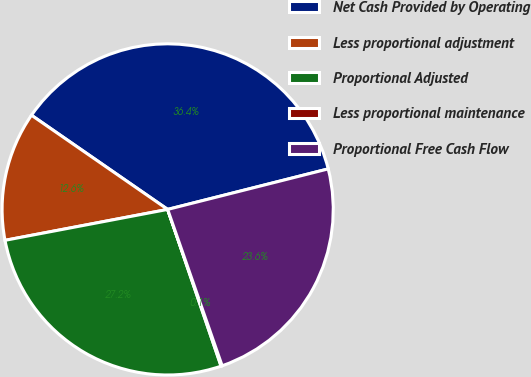<chart> <loc_0><loc_0><loc_500><loc_500><pie_chart><fcel>Net Cash Provided by Operating<fcel>Less proportional adjustment<fcel>Proportional Adjusted<fcel>Less proportional maintenance<fcel>Proportional Free Cash Flow<nl><fcel>36.44%<fcel>12.62%<fcel>27.24%<fcel>0.11%<fcel>23.6%<nl></chart> 